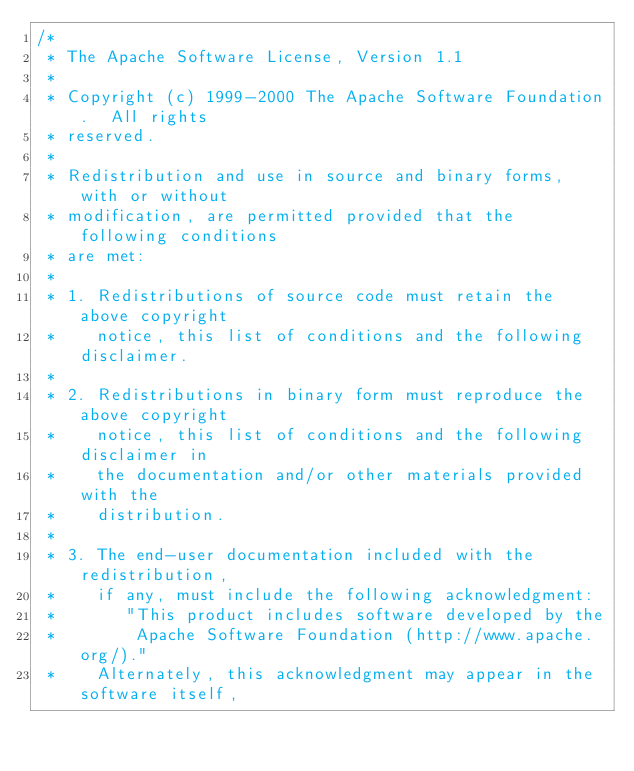Convert code to text. <code><loc_0><loc_0><loc_500><loc_500><_C++_>/*
 * The Apache Software License, Version 1.1
 * 
 * Copyright (c) 1999-2000 The Apache Software Foundation.  All rights
 * reserved.
 * 
 * Redistribution and use in source and binary forms, with or without
 * modification, are permitted provided that the following conditions
 * are met:
 * 
 * 1. Redistributions of source code must retain the above copyright
 *    notice, this list of conditions and the following disclaimer. 
 * 
 * 2. Redistributions in binary form must reproduce the above copyright
 *    notice, this list of conditions and the following disclaimer in
 *    the documentation and/or other materials provided with the
 *    distribution.
 * 
 * 3. The end-user documentation included with the redistribution,
 *    if any, must include the following acknowledgment:  
 *       "This product includes software developed by the
 *        Apache Software Foundation (http://www.apache.org/)."
 *    Alternately, this acknowledgment may appear in the software itself,</code> 